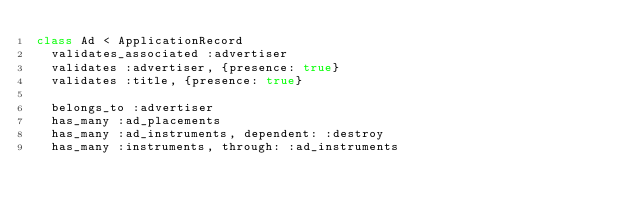<code> <loc_0><loc_0><loc_500><loc_500><_Ruby_>class Ad < ApplicationRecord
  validates_associated :advertiser
  validates :advertiser, {presence: true}
  validates :title, {presence: true}

  belongs_to :advertiser
  has_many :ad_placements
  has_many :ad_instruments, dependent: :destroy
  has_many :instruments, through: :ad_instruments
</code> 